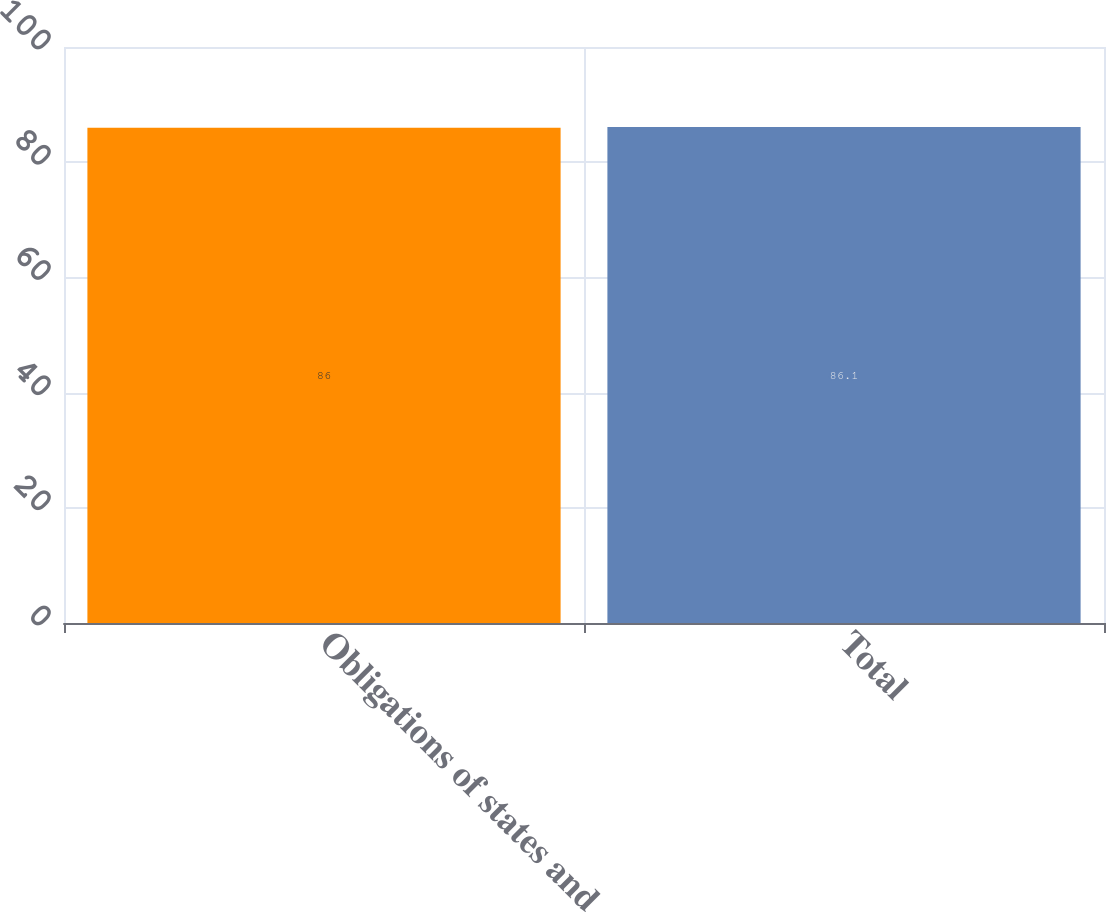Convert chart. <chart><loc_0><loc_0><loc_500><loc_500><bar_chart><fcel>Obligations of states and<fcel>Total<nl><fcel>86<fcel>86.1<nl></chart> 